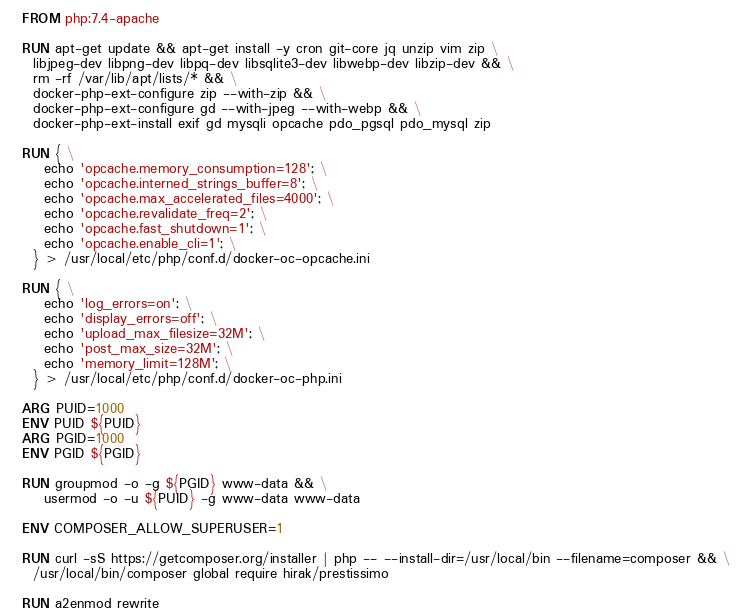Convert code to text. <code><loc_0><loc_0><loc_500><loc_500><_Dockerfile_>FROM php:7.4-apache

RUN apt-get update && apt-get install -y cron git-core jq unzip vim zip \
  libjpeg-dev libpng-dev libpq-dev libsqlite3-dev libwebp-dev libzip-dev && \
  rm -rf /var/lib/apt/lists/* && \
  docker-php-ext-configure zip --with-zip && \
  docker-php-ext-configure gd --with-jpeg --with-webp && \
  docker-php-ext-install exif gd mysqli opcache pdo_pgsql pdo_mysql zip

RUN { \
    echo 'opcache.memory_consumption=128'; \
    echo 'opcache.interned_strings_buffer=8'; \
    echo 'opcache.max_accelerated_files=4000'; \
    echo 'opcache.revalidate_freq=2'; \
    echo 'opcache.fast_shutdown=1'; \
    echo 'opcache.enable_cli=1'; \
  } > /usr/local/etc/php/conf.d/docker-oc-opcache.ini

RUN { \
    echo 'log_errors=on'; \
    echo 'display_errors=off'; \
    echo 'upload_max_filesize=32M'; \
    echo 'post_max_size=32M'; \
    echo 'memory_limit=128M'; \
  } > /usr/local/etc/php/conf.d/docker-oc-php.ini

ARG PUID=1000
ENV PUID ${PUID}
ARG PGID=1000
ENV PGID ${PGID}

RUN groupmod -o -g ${PGID} www-data && \
    usermod -o -u ${PUID} -g www-data www-data

ENV COMPOSER_ALLOW_SUPERUSER=1

RUN curl -sS https://getcomposer.org/installer | php -- --install-dir=/usr/local/bin --filename=composer && \
  /usr/local/bin/composer global require hirak/prestissimo

RUN a2enmod rewrite
</code> 